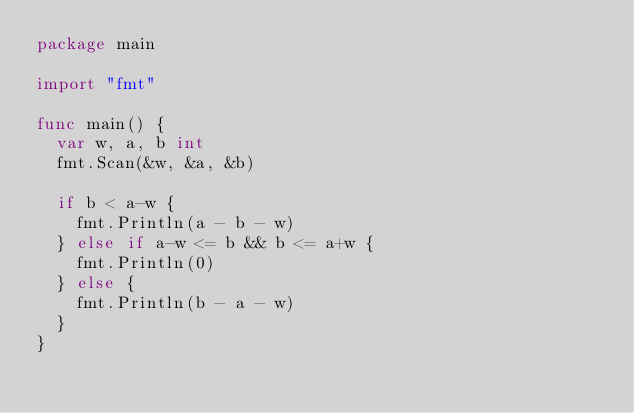<code> <loc_0><loc_0><loc_500><loc_500><_Go_>package main

import "fmt"

func main() {
	var w, a, b int
	fmt.Scan(&w, &a, &b)

	if b < a-w {
		fmt.Println(a - b - w)
	} else if a-w <= b && b <= a+w {
		fmt.Println(0)
	} else {
		fmt.Println(b - a - w)
	}
}
</code> 